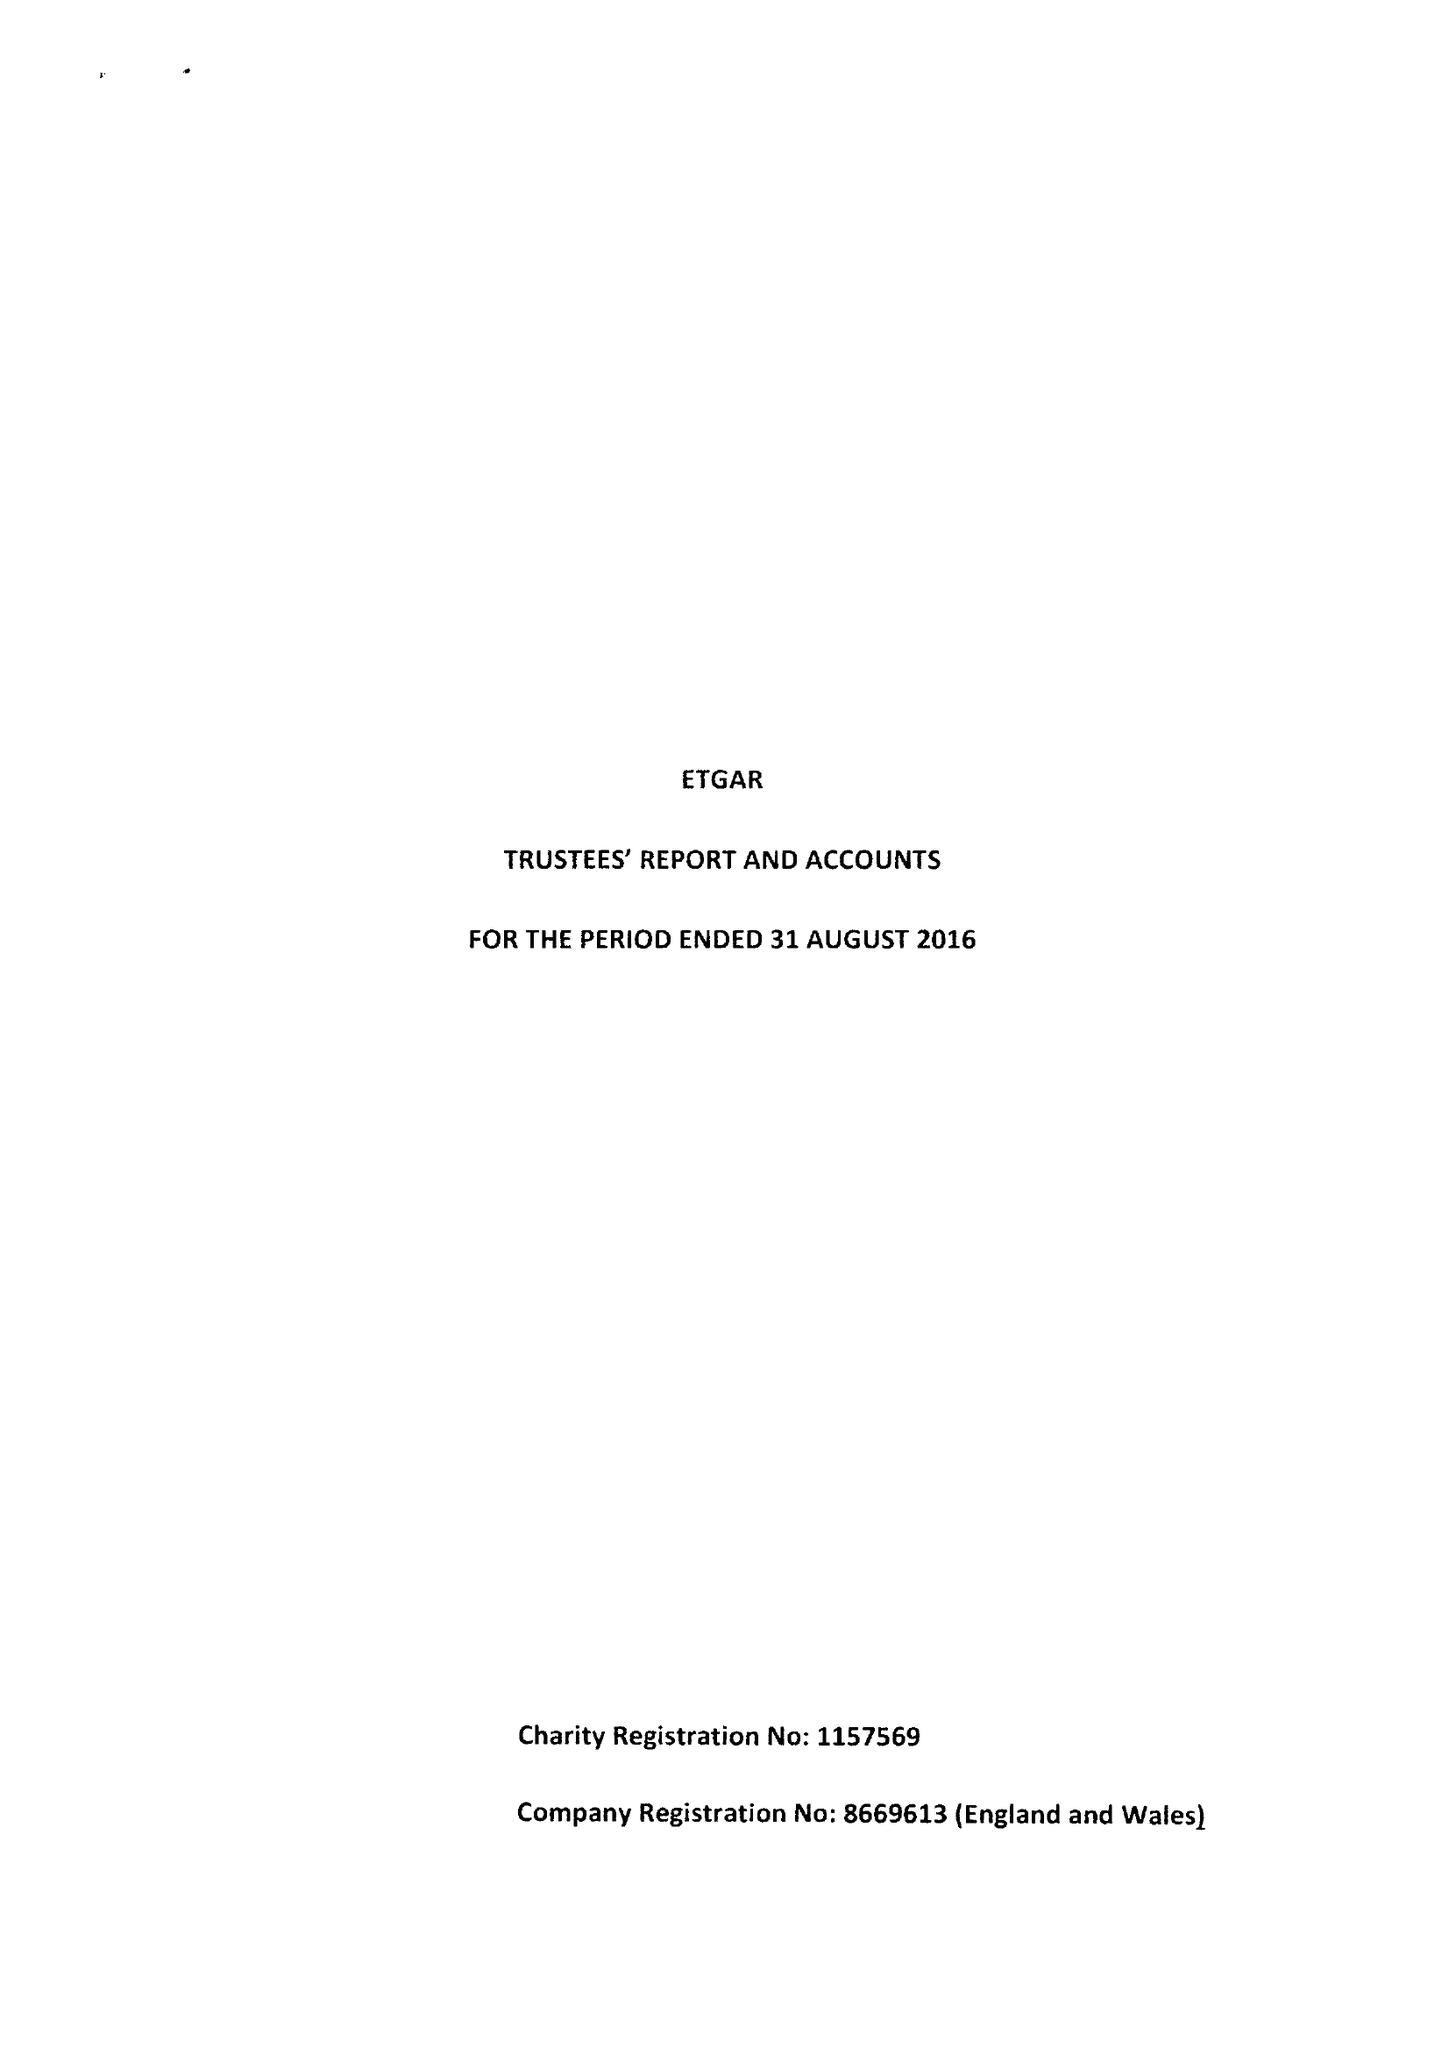What is the value for the charity_name?
Answer the question using a single word or phrase. Etgar 